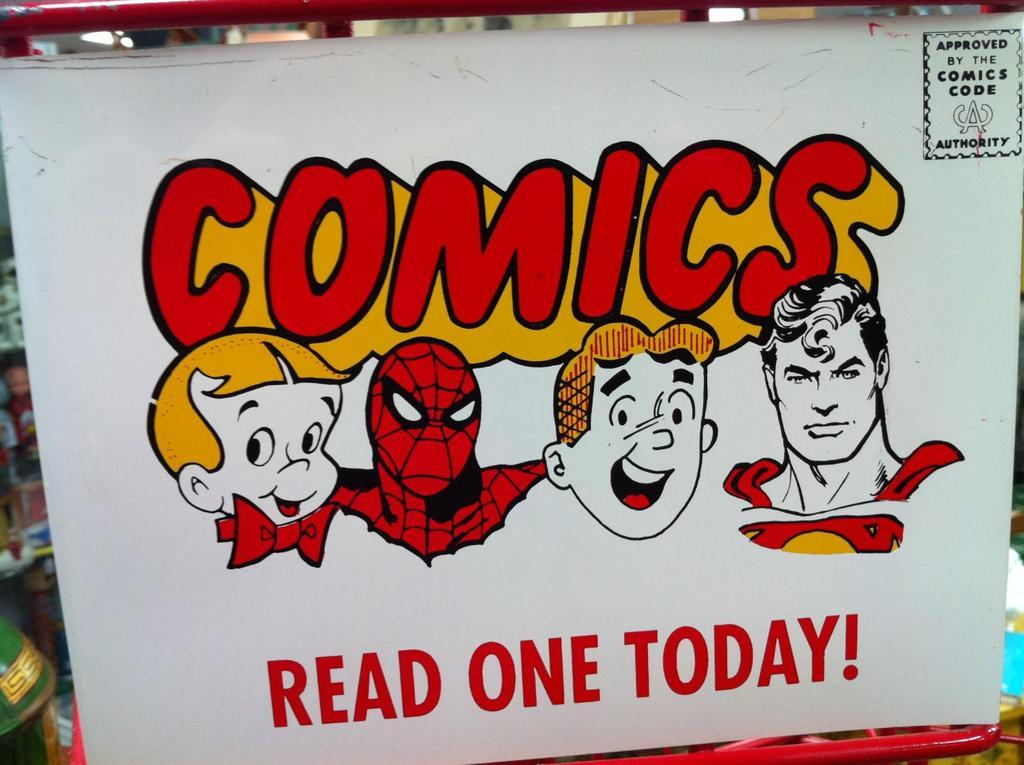What is the main object in the image? There is a white color board in the image. What is depicted on the color board? There are cartoon character faces on the board. Is there any text or writing on the color board? Yes, there is writing on the board. What type of yard can be seen in the background of the image? There is no yard visible in the image; it only features a white color board with cartoon character faces and writing. 